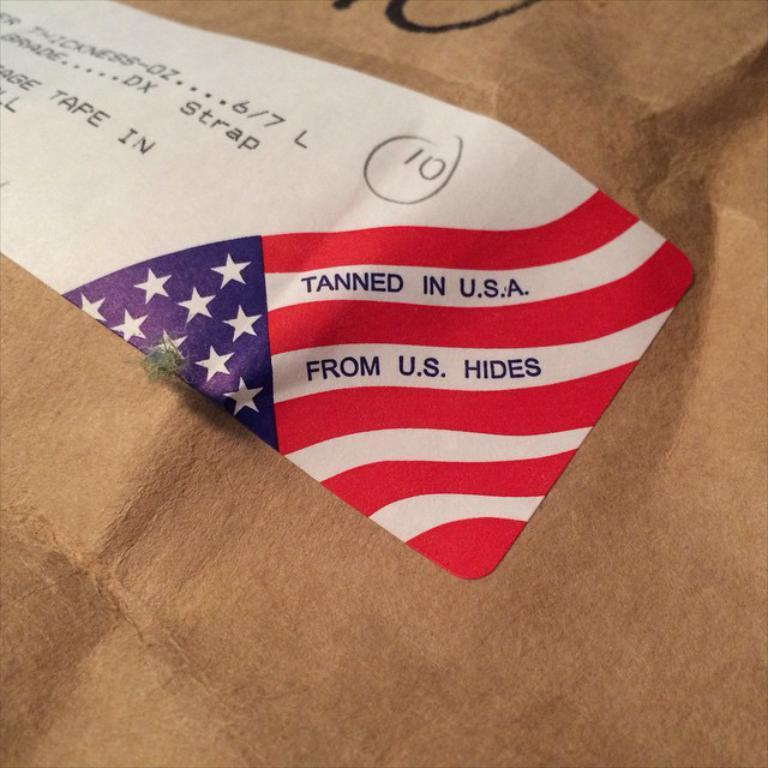Provide a one-sentence caption for the provided image. A tag that says is was made in the USA. 